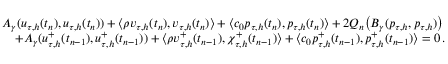<formula> <loc_0><loc_0><loc_500><loc_500>\begin{array} { r l } & { A _ { \gamma } ( \boldsymbol u _ { \tau , h } ( t _ { n } ) , \boldsymbol u _ { \tau , h } ( t _ { n } ) ) + \langle \rho \boldsymbol v _ { \tau , h } ( t _ { n } ) , \boldsymbol v _ { \tau , h } ( t _ { n } ) \rangle + \langle c _ { 0 } p _ { \tau , h } ( t _ { n } ) , p _ { \tau , h } ( t _ { n } ) \rangle + 2 Q _ { n } \left ( B _ { \gamma } ( p _ { \tau , h } , p _ { \tau , h } ) \right ) } \\ & { \quad + A _ { \gamma } ( \boldsymbol u _ { \tau , h } ^ { + } ( t _ { n - 1 } ) , \boldsymbol u _ { \tau , h } ^ { + } ( t _ { n - 1 } ) ) + \langle \rho \boldsymbol v _ { \tau , h } ^ { + } ( t _ { n - 1 } ) , \chi _ { \tau , h } ^ { + } ( t _ { n - 1 } ) \rangle + \langle c _ { 0 } p _ { \tau , h } ^ { + } ( t _ { n - 1 } ) , p _ { \tau , h } ^ { + } ( t _ { n - 1 } ) \rangle = 0 \, . } \end{array}</formula> 